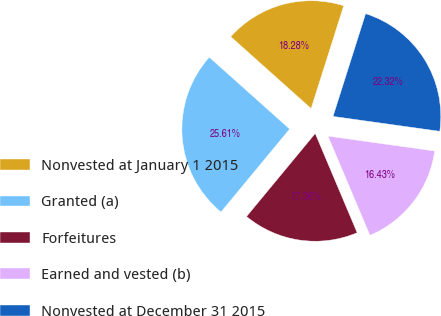Convert chart to OTSL. <chart><loc_0><loc_0><loc_500><loc_500><pie_chart><fcel>Nonvested at January 1 2015<fcel>Granted (a)<fcel>Forfeitures<fcel>Earned and vested (b)<fcel>Nonvested at December 31 2015<nl><fcel>18.28%<fcel>25.61%<fcel>17.36%<fcel>16.43%<fcel>22.32%<nl></chart> 